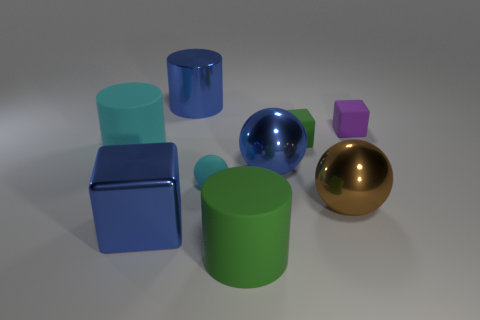How many green matte things are both in front of the blue block and behind the cyan matte ball?
Give a very brief answer. 0. Is the big cube the same color as the rubber sphere?
Make the answer very short. No. There is another small thing that is the same shape as the tiny green matte object; what is its material?
Your answer should be compact. Rubber. Is there anything else that has the same material as the brown object?
Make the answer very short. Yes. Is the number of large metal things behind the cyan sphere the same as the number of green cylinders that are behind the green cylinder?
Your answer should be very brief. No. Is the material of the cyan cylinder the same as the brown ball?
Give a very brief answer. No. How many green things are shiny spheres or large metallic blocks?
Provide a short and direct response. 0. How many large brown matte things have the same shape as the tiny purple thing?
Provide a succinct answer. 0. What material is the small cyan sphere?
Give a very brief answer. Rubber. Are there the same number of matte blocks that are in front of the green cube and tiny cyan shiny blocks?
Give a very brief answer. Yes. 